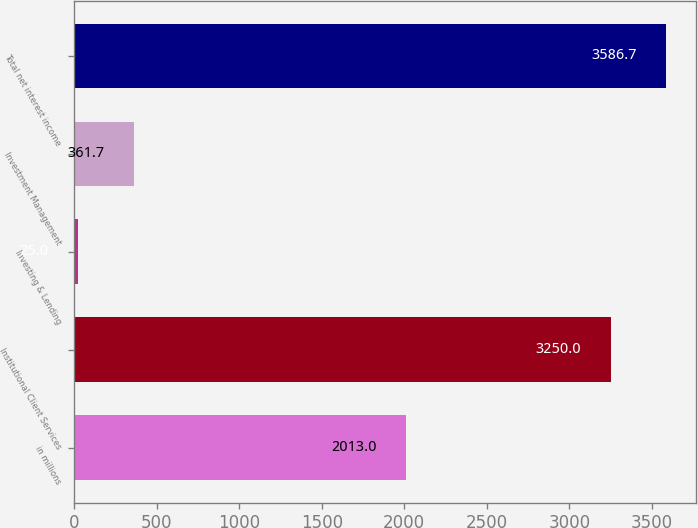Convert chart. <chart><loc_0><loc_0><loc_500><loc_500><bar_chart><fcel>in millions<fcel>Institutional Client Services<fcel>Investing & Lending<fcel>Investment Management<fcel>Total net interest income<nl><fcel>2013<fcel>3250<fcel>25<fcel>361.7<fcel>3586.7<nl></chart> 